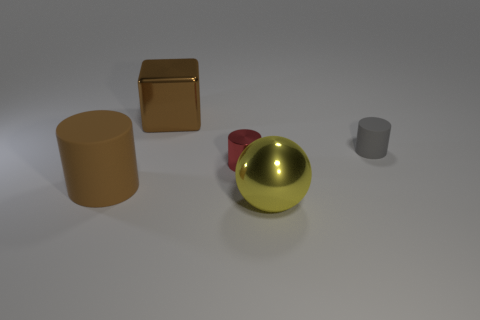Subtract all metallic cylinders. How many cylinders are left? 2 Subtract all red cylinders. How many cylinders are left? 2 Subtract 1 cylinders. How many cylinders are left? 2 Add 5 large blue spheres. How many objects exist? 10 Subtract 1 yellow balls. How many objects are left? 4 Subtract all cylinders. How many objects are left? 2 Subtract all blue spheres. Subtract all red cylinders. How many spheres are left? 1 Subtract all brown blocks. How many gray cylinders are left? 1 Subtract all small red spheres. Subtract all brown blocks. How many objects are left? 4 Add 3 metal cylinders. How many metal cylinders are left? 4 